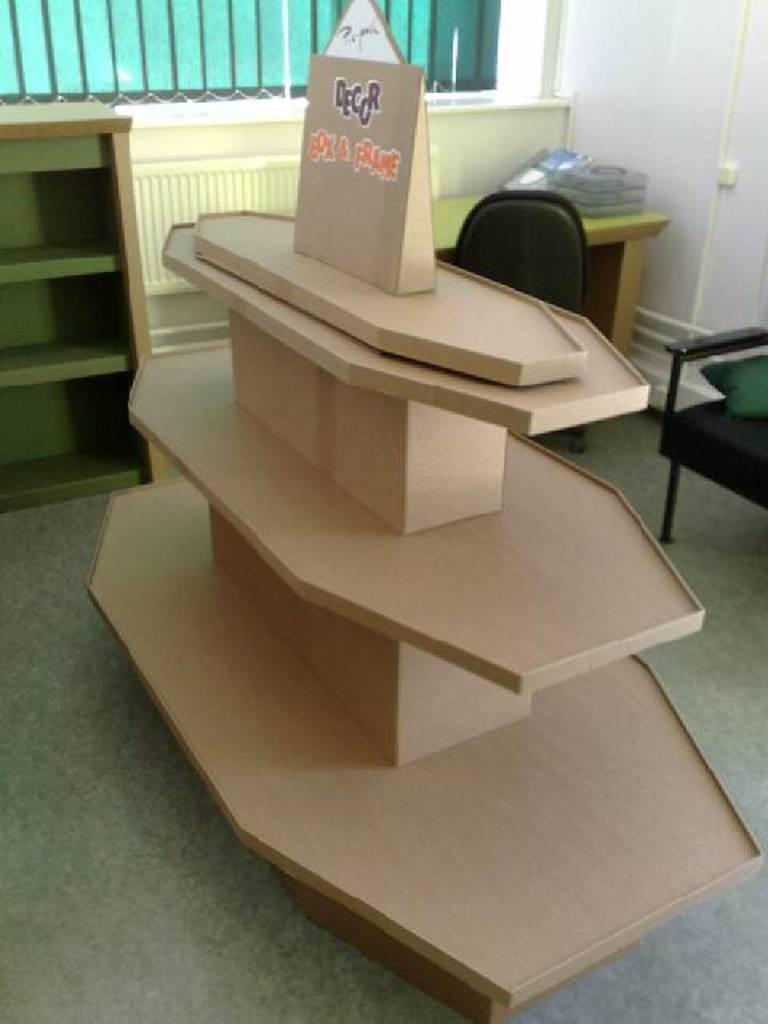Describe this image in one or two sentences. In this image I can see the rack, chair, brown color object and few objects on the table. I can see the wall and the window. 